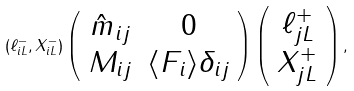<formula> <loc_0><loc_0><loc_500><loc_500>( \ell ^ { - } _ { i L } , X ^ { - } _ { i L } ) \left ( \begin{array} { c c } \hat { m } _ { i j } & 0 \\ M _ { i j } & \langle F _ { i } \rangle \delta _ { i j } \end{array} \right ) \left ( \begin{array} { c } \ell ^ { + } _ { j L } \\ X ^ { + } _ { j L } \end{array} \right ) ,</formula> 